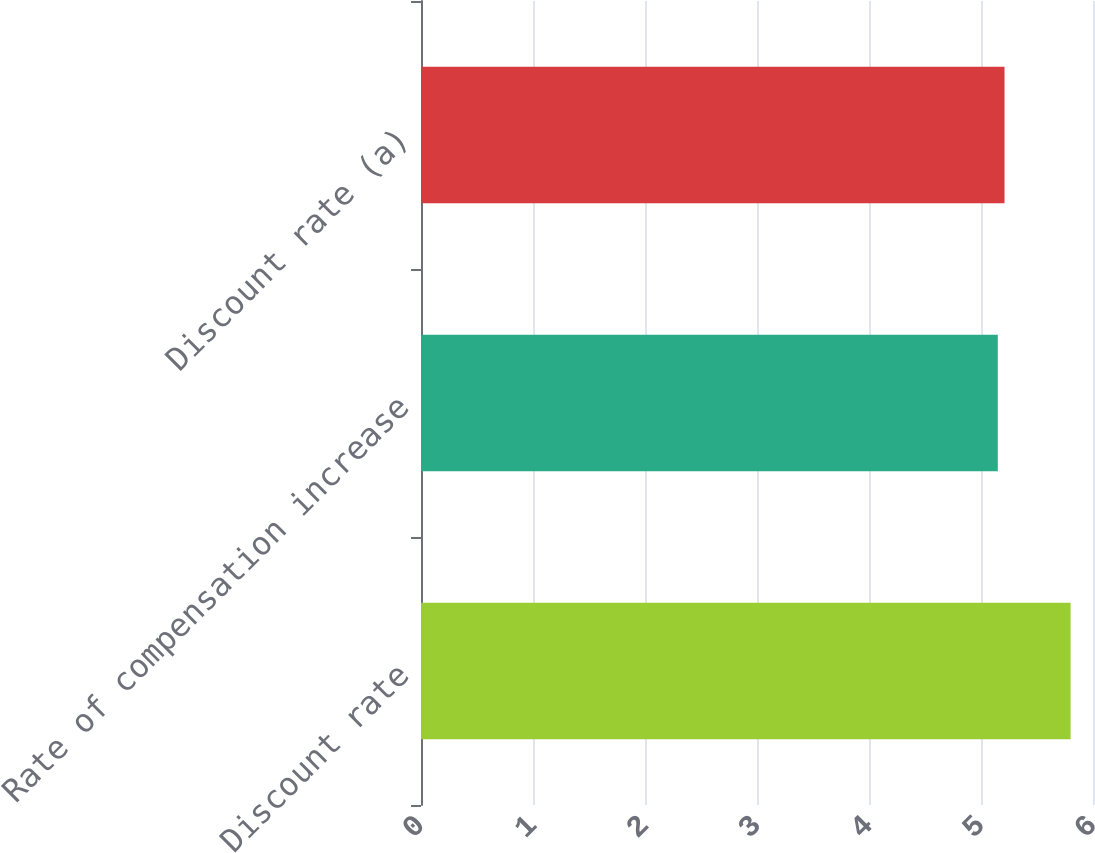Convert chart to OTSL. <chart><loc_0><loc_0><loc_500><loc_500><bar_chart><fcel>Discount rate<fcel>Rate of compensation increase<fcel>Discount rate (a)<nl><fcel>5.8<fcel>5.15<fcel>5.21<nl></chart> 